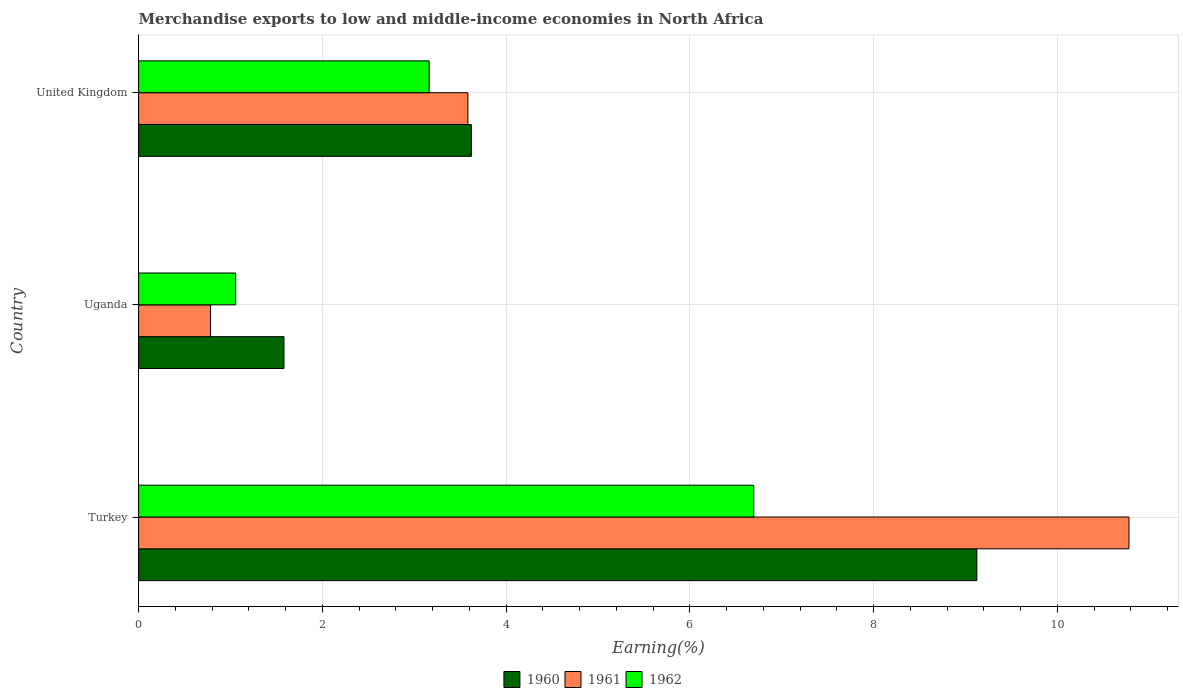How many different coloured bars are there?
Give a very brief answer. 3. Are the number of bars per tick equal to the number of legend labels?
Keep it short and to the point. Yes. Are the number of bars on each tick of the Y-axis equal?
Offer a very short reply. Yes. What is the label of the 1st group of bars from the top?
Give a very brief answer. United Kingdom. In how many cases, is the number of bars for a given country not equal to the number of legend labels?
Provide a succinct answer. 0. What is the percentage of amount earned from merchandise exports in 1962 in United Kingdom?
Offer a very short reply. 3.16. Across all countries, what is the maximum percentage of amount earned from merchandise exports in 1960?
Offer a terse response. 9.12. Across all countries, what is the minimum percentage of amount earned from merchandise exports in 1961?
Your response must be concise. 0.78. In which country was the percentage of amount earned from merchandise exports in 1961 minimum?
Give a very brief answer. Uganda. What is the total percentage of amount earned from merchandise exports in 1960 in the graph?
Offer a terse response. 14.33. What is the difference between the percentage of amount earned from merchandise exports in 1960 in Turkey and that in Uganda?
Your response must be concise. 7.54. What is the difference between the percentage of amount earned from merchandise exports in 1962 in Uganda and the percentage of amount earned from merchandise exports in 1961 in Turkey?
Offer a very short reply. -9.72. What is the average percentage of amount earned from merchandise exports in 1961 per country?
Ensure brevity in your answer.  5.05. What is the difference between the percentage of amount earned from merchandise exports in 1960 and percentage of amount earned from merchandise exports in 1962 in Turkey?
Offer a terse response. 2.43. In how many countries, is the percentage of amount earned from merchandise exports in 1961 greater than 8.8 %?
Your answer should be compact. 1. What is the ratio of the percentage of amount earned from merchandise exports in 1961 in Uganda to that in United Kingdom?
Provide a succinct answer. 0.22. Is the percentage of amount earned from merchandise exports in 1961 in Turkey less than that in United Kingdom?
Keep it short and to the point. No. What is the difference between the highest and the second highest percentage of amount earned from merchandise exports in 1961?
Provide a succinct answer. 7.19. What is the difference between the highest and the lowest percentage of amount earned from merchandise exports in 1961?
Ensure brevity in your answer.  10. What does the 1st bar from the top in Uganda represents?
Offer a very short reply. 1962. What does the 3rd bar from the bottom in Uganda represents?
Make the answer very short. 1962. How many countries are there in the graph?
Provide a succinct answer. 3. Does the graph contain any zero values?
Offer a very short reply. No. How are the legend labels stacked?
Ensure brevity in your answer.  Horizontal. What is the title of the graph?
Keep it short and to the point. Merchandise exports to low and middle-income economies in North Africa. What is the label or title of the X-axis?
Make the answer very short. Earning(%). What is the label or title of the Y-axis?
Provide a succinct answer. Country. What is the Earning(%) in 1960 in Turkey?
Your answer should be very brief. 9.12. What is the Earning(%) in 1961 in Turkey?
Provide a short and direct response. 10.78. What is the Earning(%) of 1962 in Turkey?
Provide a short and direct response. 6.69. What is the Earning(%) in 1960 in Uganda?
Your answer should be compact. 1.58. What is the Earning(%) of 1961 in Uganda?
Your response must be concise. 0.78. What is the Earning(%) in 1962 in Uganda?
Your answer should be compact. 1.06. What is the Earning(%) of 1960 in United Kingdom?
Your response must be concise. 3.62. What is the Earning(%) in 1961 in United Kingdom?
Ensure brevity in your answer.  3.58. What is the Earning(%) of 1962 in United Kingdom?
Offer a very short reply. 3.16. Across all countries, what is the maximum Earning(%) in 1960?
Ensure brevity in your answer.  9.12. Across all countries, what is the maximum Earning(%) in 1961?
Provide a short and direct response. 10.78. Across all countries, what is the maximum Earning(%) in 1962?
Offer a terse response. 6.69. Across all countries, what is the minimum Earning(%) in 1960?
Your answer should be very brief. 1.58. Across all countries, what is the minimum Earning(%) of 1961?
Ensure brevity in your answer.  0.78. Across all countries, what is the minimum Earning(%) in 1962?
Keep it short and to the point. 1.06. What is the total Earning(%) in 1960 in the graph?
Give a very brief answer. 14.33. What is the total Earning(%) of 1961 in the graph?
Keep it short and to the point. 15.14. What is the total Earning(%) of 1962 in the graph?
Make the answer very short. 10.91. What is the difference between the Earning(%) of 1960 in Turkey and that in Uganda?
Provide a succinct answer. 7.54. What is the difference between the Earning(%) of 1961 in Turkey and that in Uganda?
Provide a short and direct response. 10. What is the difference between the Earning(%) in 1962 in Turkey and that in Uganda?
Offer a terse response. 5.64. What is the difference between the Earning(%) of 1960 in Turkey and that in United Kingdom?
Make the answer very short. 5.5. What is the difference between the Earning(%) of 1961 in Turkey and that in United Kingdom?
Offer a very short reply. 7.19. What is the difference between the Earning(%) of 1962 in Turkey and that in United Kingdom?
Your response must be concise. 3.53. What is the difference between the Earning(%) of 1960 in Uganda and that in United Kingdom?
Offer a terse response. -2.04. What is the difference between the Earning(%) of 1961 in Uganda and that in United Kingdom?
Your answer should be compact. -2.8. What is the difference between the Earning(%) in 1962 in Uganda and that in United Kingdom?
Ensure brevity in your answer.  -2.11. What is the difference between the Earning(%) of 1960 in Turkey and the Earning(%) of 1961 in Uganda?
Your answer should be compact. 8.34. What is the difference between the Earning(%) in 1960 in Turkey and the Earning(%) in 1962 in Uganda?
Your answer should be compact. 8.07. What is the difference between the Earning(%) of 1961 in Turkey and the Earning(%) of 1962 in Uganda?
Keep it short and to the point. 9.72. What is the difference between the Earning(%) of 1960 in Turkey and the Earning(%) of 1961 in United Kingdom?
Your answer should be compact. 5.54. What is the difference between the Earning(%) of 1960 in Turkey and the Earning(%) of 1962 in United Kingdom?
Provide a short and direct response. 5.96. What is the difference between the Earning(%) in 1961 in Turkey and the Earning(%) in 1962 in United Kingdom?
Provide a short and direct response. 7.62. What is the difference between the Earning(%) of 1960 in Uganda and the Earning(%) of 1961 in United Kingdom?
Offer a terse response. -2. What is the difference between the Earning(%) in 1960 in Uganda and the Earning(%) in 1962 in United Kingdom?
Your response must be concise. -1.58. What is the difference between the Earning(%) in 1961 in Uganda and the Earning(%) in 1962 in United Kingdom?
Your response must be concise. -2.38. What is the average Earning(%) in 1960 per country?
Offer a terse response. 4.78. What is the average Earning(%) in 1961 per country?
Offer a terse response. 5.05. What is the average Earning(%) of 1962 per country?
Your response must be concise. 3.64. What is the difference between the Earning(%) of 1960 and Earning(%) of 1961 in Turkey?
Provide a succinct answer. -1.66. What is the difference between the Earning(%) in 1960 and Earning(%) in 1962 in Turkey?
Make the answer very short. 2.43. What is the difference between the Earning(%) in 1961 and Earning(%) in 1962 in Turkey?
Offer a terse response. 4.08. What is the difference between the Earning(%) of 1960 and Earning(%) of 1961 in Uganda?
Make the answer very short. 0.8. What is the difference between the Earning(%) in 1960 and Earning(%) in 1962 in Uganda?
Offer a terse response. 0.53. What is the difference between the Earning(%) of 1961 and Earning(%) of 1962 in Uganda?
Offer a very short reply. -0.27. What is the difference between the Earning(%) of 1960 and Earning(%) of 1961 in United Kingdom?
Your answer should be very brief. 0.04. What is the difference between the Earning(%) in 1960 and Earning(%) in 1962 in United Kingdom?
Offer a very short reply. 0.46. What is the difference between the Earning(%) in 1961 and Earning(%) in 1962 in United Kingdom?
Your answer should be very brief. 0.42. What is the ratio of the Earning(%) of 1960 in Turkey to that in Uganda?
Make the answer very short. 5.77. What is the ratio of the Earning(%) of 1961 in Turkey to that in Uganda?
Provide a succinct answer. 13.77. What is the ratio of the Earning(%) in 1962 in Turkey to that in Uganda?
Your answer should be compact. 6.34. What is the ratio of the Earning(%) of 1960 in Turkey to that in United Kingdom?
Your response must be concise. 2.52. What is the ratio of the Earning(%) in 1961 in Turkey to that in United Kingdom?
Make the answer very short. 3.01. What is the ratio of the Earning(%) of 1962 in Turkey to that in United Kingdom?
Give a very brief answer. 2.12. What is the ratio of the Earning(%) in 1960 in Uganda to that in United Kingdom?
Provide a succinct answer. 0.44. What is the ratio of the Earning(%) of 1961 in Uganda to that in United Kingdom?
Provide a short and direct response. 0.22. What is the ratio of the Earning(%) of 1962 in Uganda to that in United Kingdom?
Offer a very short reply. 0.33. What is the difference between the highest and the second highest Earning(%) of 1960?
Keep it short and to the point. 5.5. What is the difference between the highest and the second highest Earning(%) in 1961?
Make the answer very short. 7.19. What is the difference between the highest and the second highest Earning(%) in 1962?
Your response must be concise. 3.53. What is the difference between the highest and the lowest Earning(%) in 1960?
Give a very brief answer. 7.54. What is the difference between the highest and the lowest Earning(%) in 1961?
Provide a succinct answer. 10. What is the difference between the highest and the lowest Earning(%) of 1962?
Make the answer very short. 5.64. 